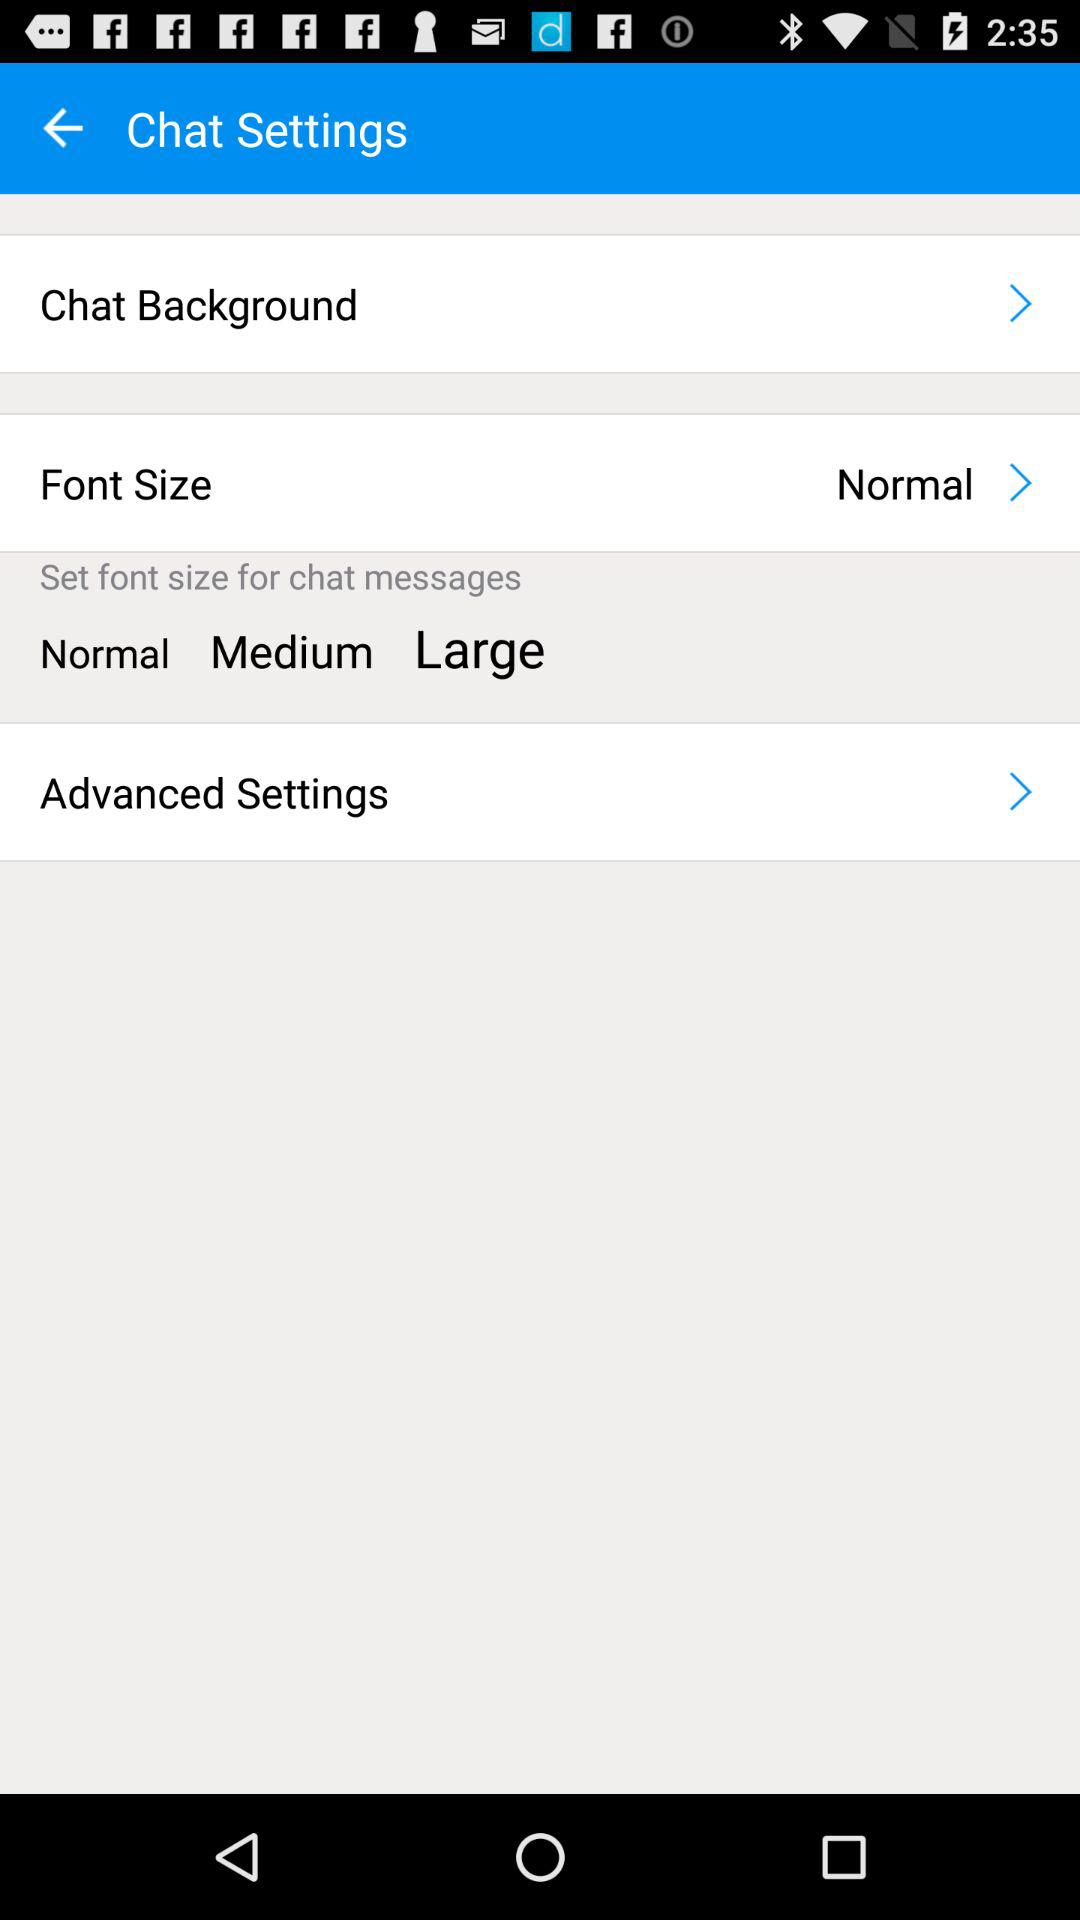What is the font size? The font size is "Normal". 